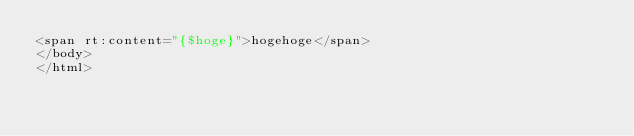Convert code to text. <code><loc_0><loc_0><loc_500><loc_500><_HTML_><span rt:content="{$hoge}">hogehoge</span>
</body>
</html></code> 